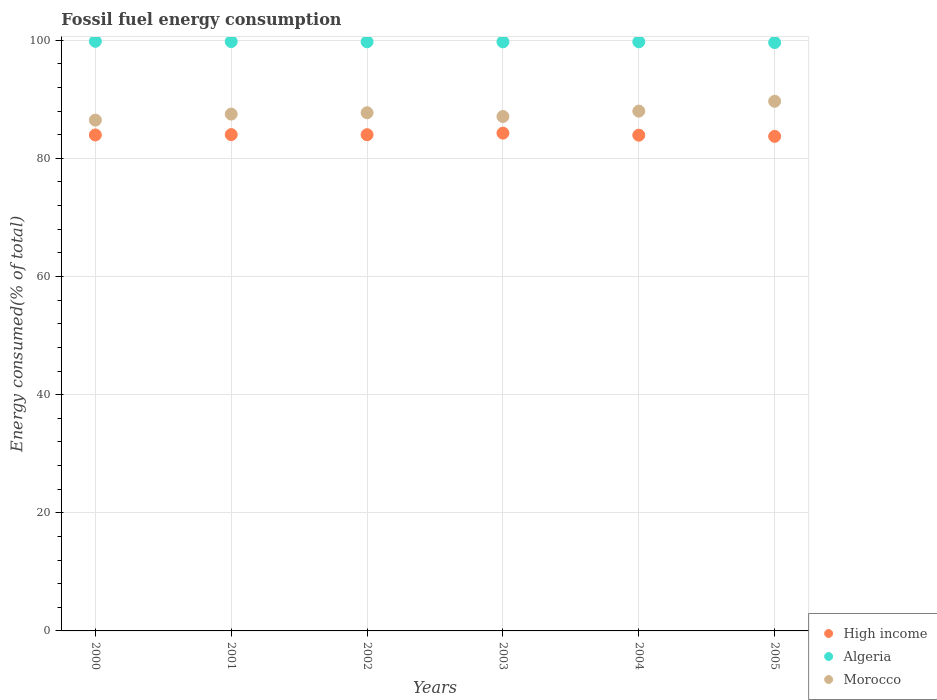How many different coloured dotlines are there?
Your response must be concise. 3. What is the percentage of energy consumed in Algeria in 2004?
Offer a very short reply. 99.74. Across all years, what is the maximum percentage of energy consumed in High income?
Provide a short and direct response. 84.27. Across all years, what is the minimum percentage of energy consumed in Morocco?
Your answer should be compact. 86.48. In which year was the percentage of energy consumed in Algeria maximum?
Provide a succinct answer. 2000. What is the total percentage of energy consumed in Morocco in the graph?
Your response must be concise. 526.45. What is the difference between the percentage of energy consumed in Morocco in 2002 and that in 2005?
Give a very brief answer. -1.94. What is the difference between the percentage of energy consumed in High income in 2002 and the percentage of energy consumed in Morocco in 2005?
Give a very brief answer. -5.66. What is the average percentage of energy consumed in Morocco per year?
Your response must be concise. 87.74. In the year 2002, what is the difference between the percentage of energy consumed in Algeria and percentage of energy consumed in High income?
Offer a very short reply. 15.73. What is the ratio of the percentage of energy consumed in Morocco in 2000 to that in 2002?
Your answer should be very brief. 0.99. Is the difference between the percentage of energy consumed in Algeria in 2002 and 2004 greater than the difference between the percentage of energy consumed in High income in 2002 and 2004?
Offer a very short reply. No. What is the difference between the highest and the second highest percentage of energy consumed in Algeria?
Make the answer very short. 0.04. What is the difference between the highest and the lowest percentage of energy consumed in Algeria?
Your answer should be very brief. 0.21. Is the sum of the percentage of energy consumed in Morocco in 2002 and 2005 greater than the maximum percentage of energy consumed in High income across all years?
Your response must be concise. Yes. How many dotlines are there?
Give a very brief answer. 3. Where does the legend appear in the graph?
Give a very brief answer. Bottom right. How many legend labels are there?
Provide a short and direct response. 3. How are the legend labels stacked?
Make the answer very short. Vertical. What is the title of the graph?
Keep it short and to the point. Fossil fuel energy consumption. What is the label or title of the X-axis?
Your answer should be very brief. Years. What is the label or title of the Y-axis?
Provide a succinct answer. Energy consumed(% of total). What is the Energy consumed(% of total) in High income in 2000?
Provide a succinct answer. 83.96. What is the Energy consumed(% of total) in Algeria in 2000?
Your answer should be very brief. 99.82. What is the Energy consumed(% of total) of Morocco in 2000?
Provide a succinct answer. 86.48. What is the Energy consumed(% of total) of High income in 2001?
Ensure brevity in your answer.  84.02. What is the Energy consumed(% of total) in Algeria in 2001?
Provide a short and direct response. 99.78. What is the Energy consumed(% of total) in Morocco in 2001?
Make the answer very short. 87.49. What is the Energy consumed(% of total) in High income in 2002?
Keep it short and to the point. 84. What is the Energy consumed(% of total) in Algeria in 2002?
Offer a terse response. 99.74. What is the Energy consumed(% of total) in Morocco in 2002?
Provide a short and direct response. 87.72. What is the Energy consumed(% of total) of High income in 2003?
Your answer should be very brief. 84.27. What is the Energy consumed(% of total) in Algeria in 2003?
Keep it short and to the point. 99.73. What is the Energy consumed(% of total) of Morocco in 2003?
Make the answer very short. 87.09. What is the Energy consumed(% of total) in High income in 2004?
Ensure brevity in your answer.  83.93. What is the Energy consumed(% of total) in Algeria in 2004?
Give a very brief answer. 99.74. What is the Energy consumed(% of total) of Morocco in 2004?
Provide a succinct answer. 88. What is the Energy consumed(% of total) of High income in 2005?
Make the answer very short. 83.73. What is the Energy consumed(% of total) in Algeria in 2005?
Your answer should be compact. 99.61. What is the Energy consumed(% of total) of Morocco in 2005?
Your response must be concise. 89.67. Across all years, what is the maximum Energy consumed(% of total) in High income?
Give a very brief answer. 84.27. Across all years, what is the maximum Energy consumed(% of total) of Algeria?
Keep it short and to the point. 99.82. Across all years, what is the maximum Energy consumed(% of total) in Morocco?
Make the answer very short. 89.67. Across all years, what is the minimum Energy consumed(% of total) of High income?
Provide a short and direct response. 83.73. Across all years, what is the minimum Energy consumed(% of total) in Algeria?
Provide a short and direct response. 99.61. Across all years, what is the minimum Energy consumed(% of total) in Morocco?
Provide a succinct answer. 86.48. What is the total Energy consumed(% of total) in High income in the graph?
Offer a very short reply. 503.92. What is the total Energy consumed(% of total) of Algeria in the graph?
Give a very brief answer. 598.41. What is the total Energy consumed(% of total) in Morocco in the graph?
Provide a succinct answer. 526.45. What is the difference between the Energy consumed(% of total) in High income in 2000 and that in 2001?
Give a very brief answer. -0.06. What is the difference between the Energy consumed(% of total) of Algeria in 2000 and that in 2001?
Ensure brevity in your answer.  0.04. What is the difference between the Energy consumed(% of total) in Morocco in 2000 and that in 2001?
Give a very brief answer. -1.02. What is the difference between the Energy consumed(% of total) of High income in 2000 and that in 2002?
Make the answer very short. -0.04. What is the difference between the Energy consumed(% of total) in Algeria in 2000 and that in 2002?
Keep it short and to the point. 0.08. What is the difference between the Energy consumed(% of total) of Morocco in 2000 and that in 2002?
Offer a very short reply. -1.25. What is the difference between the Energy consumed(% of total) of High income in 2000 and that in 2003?
Offer a terse response. -0.31. What is the difference between the Energy consumed(% of total) of Algeria in 2000 and that in 2003?
Offer a terse response. 0.08. What is the difference between the Energy consumed(% of total) of Morocco in 2000 and that in 2003?
Your response must be concise. -0.61. What is the difference between the Energy consumed(% of total) of High income in 2000 and that in 2004?
Your answer should be very brief. 0.04. What is the difference between the Energy consumed(% of total) of Algeria in 2000 and that in 2004?
Ensure brevity in your answer.  0.08. What is the difference between the Energy consumed(% of total) in Morocco in 2000 and that in 2004?
Ensure brevity in your answer.  -1.52. What is the difference between the Energy consumed(% of total) of High income in 2000 and that in 2005?
Your answer should be very brief. 0.24. What is the difference between the Energy consumed(% of total) of Algeria in 2000 and that in 2005?
Provide a short and direct response. 0.21. What is the difference between the Energy consumed(% of total) in Morocco in 2000 and that in 2005?
Make the answer very short. -3.19. What is the difference between the Energy consumed(% of total) of High income in 2001 and that in 2002?
Provide a short and direct response. 0.02. What is the difference between the Energy consumed(% of total) in Algeria in 2001 and that in 2002?
Provide a succinct answer. 0.04. What is the difference between the Energy consumed(% of total) of Morocco in 2001 and that in 2002?
Your response must be concise. -0.23. What is the difference between the Energy consumed(% of total) of High income in 2001 and that in 2003?
Offer a very short reply. -0.25. What is the difference between the Energy consumed(% of total) in Algeria in 2001 and that in 2003?
Make the answer very short. 0.04. What is the difference between the Energy consumed(% of total) in Morocco in 2001 and that in 2003?
Give a very brief answer. 0.4. What is the difference between the Energy consumed(% of total) in High income in 2001 and that in 2004?
Offer a terse response. 0.1. What is the difference between the Energy consumed(% of total) of Algeria in 2001 and that in 2004?
Offer a terse response. 0.04. What is the difference between the Energy consumed(% of total) of Morocco in 2001 and that in 2004?
Provide a succinct answer. -0.5. What is the difference between the Energy consumed(% of total) in High income in 2001 and that in 2005?
Offer a very short reply. 0.3. What is the difference between the Energy consumed(% of total) in Algeria in 2001 and that in 2005?
Ensure brevity in your answer.  0.17. What is the difference between the Energy consumed(% of total) of Morocco in 2001 and that in 2005?
Keep it short and to the point. -2.17. What is the difference between the Energy consumed(% of total) in High income in 2002 and that in 2003?
Keep it short and to the point. -0.27. What is the difference between the Energy consumed(% of total) of Algeria in 2002 and that in 2003?
Your answer should be very brief. 0.01. What is the difference between the Energy consumed(% of total) in Morocco in 2002 and that in 2003?
Your response must be concise. 0.63. What is the difference between the Energy consumed(% of total) in High income in 2002 and that in 2004?
Make the answer very short. 0.08. What is the difference between the Energy consumed(% of total) of Algeria in 2002 and that in 2004?
Your answer should be compact. 0. What is the difference between the Energy consumed(% of total) of Morocco in 2002 and that in 2004?
Provide a short and direct response. -0.27. What is the difference between the Energy consumed(% of total) in High income in 2002 and that in 2005?
Ensure brevity in your answer.  0.28. What is the difference between the Energy consumed(% of total) in Algeria in 2002 and that in 2005?
Your answer should be compact. 0.13. What is the difference between the Energy consumed(% of total) in Morocco in 2002 and that in 2005?
Give a very brief answer. -1.94. What is the difference between the Energy consumed(% of total) in High income in 2003 and that in 2004?
Your answer should be compact. 0.35. What is the difference between the Energy consumed(% of total) in Algeria in 2003 and that in 2004?
Provide a succinct answer. -0.01. What is the difference between the Energy consumed(% of total) in Morocco in 2003 and that in 2004?
Offer a very short reply. -0.91. What is the difference between the Energy consumed(% of total) in High income in 2003 and that in 2005?
Your answer should be compact. 0.55. What is the difference between the Energy consumed(% of total) of Algeria in 2003 and that in 2005?
Your response must be concise. 0.12. What is the difference between the Energy consumed(% of total) of Morocco in 2003 and that in 2005?
Your answer should be compact. -2.57. What is the difference between the Energy consumed(% of total) of High income in 2004 and that in 2005?
Keep it short and to the point. 0.2. What is the difference between the Energy consumed(% of total) of Algeria in 2004 and that in 2005?
Your answer should be very brief. 0.13. What is the difference between the Energy consumed(% of total) in Morocco in 2004 and that in 2005?
Make the answer very short. -1.67. What is the difference between the Energy consumed(% of total) of High income in 2000 and the Energy consumed(% of total) of Algeria in 2001?
Provide a succinct answer. -15.81. What is the difference between the Energy consumed(% of total) of High income in 2000 and the Energy consumed(% of total) of Morocco in 2001?
Offer a very short reply. -3.53. What is the difference between the Energy consumed(% of total) of Algeria in 2000 and the Energy consumed(% of total) of Morocco in 2001?
Provide a succinct answer. 12.32. What is the difference between the Energy consumed(% of total) of High income in 2000 and the Energy consumed(% of total) of Algeria in 2002?
Your answer should be very brief. -15.78. What is the difference between the Energy consumed(% of total) in High income in 2000 and the Energy consumed(% of total) in Morocco in 2002?
Provide a short and direct response. -3.76. What is the difference between the Energy consumed(% of total) of Algeria in 2000 and the Energy consumed(% of total) of Morocco in 2002?
Give a very brief answer. 12.09. What is the difference between the Energy consumed(% of total) of High income in 2000 and the Energy consumed(% of total) of Algeria in 2003?
Offer a very short reply. -15.77. What is the difference between the Energy consumed(% of total) in High income in 2000 and the Energy consumed(% of total) in Morocco in 2003?
Provide a succinct answer. -3.13. What is the difference between the Energy consumed(% of total) of Algeria in 2000 and the Energy consumed(% of total) of Morocco in 2003?
Ensure brevity in your answer.  12.72. What is the difference between the Energy consumed(% of total) in High income in 2000 and the Energy consumed(% of total) in Algeria in 2004?
Your response must be concise. -15.77. What is the difference between the Energy consumed(% of total) of High income in 2000 and the Energy consumed(% of total) of Morocco in 2004?
Provide a short and direct response. -4.04. What is the difference between the Energy consumed(% of total) in Algeria in 2000 and the Energy consumed(% of total) in Morocco in 2004?
Give a very brief answer. 11.82. What is the difference between the Energy consumed(% of total) in High income in 2000 and the Energy consumed(% of total) in Algeria in 2005?
Your response must be concise. -15.65. What is the difference between the Energy consumed(% of total) in High income in 2000 and the Energy consumed(% of total) in Morocco in 2005?
Your answer should be very brief. -5.7. What is the difference between the Energy consumed(% of total) in Algeria in 2000 and the Energy consumed(% of total) in Morocco in 2005?
Give a very brief answer. 10.15. What is the difference between the Energy consumed(% of total) of High income in 2001 and the Energy consumed(% of total) of Algeria in 2002?
Keep it short and to the point. -15.71. What is the difference between the Energy consumed(% of total) of High income in 2001 and the Energy consumed(% of total) of Morocco in 2002?
Ensure brevity in your answer.  -3.7. What is the difference between the Energy consumed(% of total) in Algeria in 2001 and the Energy consumed(% of total) in Morocco in 2002?
Your answer should be very brief. 12.05. What is the difference between the Energy consumed(% of total) in High income in 2001 and the Energy consumed(% of total) in Algeria in 2003?
Your answer should be very brief. -15.71. What is the difference between the Energy consumed(% of total) of High income in 2001 and the Energy consumed(% of total) of Morocco in 2003?
Ensure brevity in your answer.  -3.07. What is the difference between the Energy consumed(% of total) in Algeria in 2001 and the Energy consumed(% of total) in Morocco in 2003?
Provide a succinct answer. 12.68. What is the difference between the Energy consumed(% of total) of High income in 2001 and the Energy consumed(% of total) of Algeria in 2004?
Provide a succinct answer. -15.71. What is the difference between the Energy consumed(% of total) in High income in 2001 and the Energy consumed(% of total) in Morocco in 2004?
Your answer should be compact. -3.97. What is the difference between the Energy consumed(% of total) in Algeria in 2001 and the Energy consumed(% of total) in Morocco in 2004?
Your answer should be very brief. 11.78. What is the difference between the Energy consumed(% of total) in High income in 2001 and the Energy consumed(% of total) in Algeria in 2005?
Ensure brevity in your answer.  -15.59. What is the difference between the Energy consumed(% of total) of High income in 2001 and the Energy consumed(% of total) of Morocco in 2005?
Provide a succinct answer. -5.64. What is the difference between the Energy consumed(% of total) of Algeria in 2001 and the Energy consumed(% of total) of Morocco in 2005?
Offer a terse response. 10.11. What is the difference between the Energy consumed(% of total) of High income in 2002 and the Energy consumed(% of total) of Algeria in 2003?
Ensure brevity in your answer.  -15.73. What is the difference between the Energy consumed(% of total) of High income in 2002 and the Energy consumed(% of total) of Morocco in 2003?
Give a very brief answer. -3.09. What is the difference between the Energy consumed(% of total) in Algeria in 2002 and the Energy consumed(% of total) in Morocco in 2003?
Provide a short and direct response. 12.65. What is the difference between the Energy consumed(% of total) in High income in 2002 and the Energy consumed(% of total) in Algeria in 2004?
Make the answer very short. -15.73. What is the difference between the Energy consumed(% of total) of High income in 2002 and the Energy consumed(% of total) of Morocco in 2004?
Offer a terse response. -3.99. What is the difference between the Energy consumed(% of total) in Algeria in 2002 and the Energy consumed(% of total) in Morocco in 2004?
Provide a short and direct response. 11.74. What is the difference between the Energy consumed(% of total) in High income in 2002 and the Energy consumed(% of total) in Algeria in 2005?
Keep it short and to the point. -15.6. What is the difference between the Energy consumed(% of total) of High income in 2002 and the Energy consumed(% of total) of Morocco in 2005?
Give a very brief answer. -5.66. What is the difference between the Energy consumed(% of total) in Algeria in 2002 and the Energy consumed(% of total) in Morocco in 2005?
Provide a succinct answer. 10.07. What is the difference between the Energy consumed(% of total) in High income in 2003 and the Energy consumed(% of total) in Algeria in 2004?
Offer a very short reply. -15.46. What is the difference between the Energy consumed(% of total) in High income in 2003 and the Energy consumed(% of total) in Morocco in 2004?
Ensure brevity in your answer.  -3.72. What is the difference between the Energy consumed(% of total) of Algeria in 2003 and the Energy consumed(% of total) of Morocco in 2004?
Offer a terse response. 11.73. What is the difference between the Energy consumed(% of total) of High income in 2003 and the Energy consumed(% of total) of Algeria in 2005?
Offer a terse response. -15.34. What is the difference between the Energy consumed(% of total) in High income in 2003 and the Energy consumed(% of total) in Morocco in 2005?
Provide a short and direct response. -5.39. What is the difference between the Energy consumed(% of total) in Algeria in 2003 and the Energy consumed(% of total) in Morocco in 2005?
Keep it short and to the point. 10.07. What is the difference between the Energy consumed(% of total) in High income in 2004 and the Energy consumed(% of total) in Algeria in 2005?
Provide a short and direct response. -15.68. What is the difference between the Energy consumed(% of total) of High income in 2004 and the Energy consumed(% of total) of Morocco in 2005?
Your answer should be very brief. -5.74. What is the difference between the Energy consumed(% of total) in Algeria in 2004 and the Energy consumed(% of total) in Morocco in 2005?
Give a very brief answer. 10.07. What is the average Energy consumed(% of total) in High income per year?
Offer a very short reply. 83.99. What is the average Energy consumed(% of total) in Algeria per year?
Your answer should be very brief. 99.73. What is the average Energy consumed(% of total) of Morocco per year?
Provide a succinct answer. 87.74. In the year 2000, what is the difference between the Energy consumed(% of total) in High income and Energy consumed(% of total) in Algeria?
Offer a terse response. -15.85. In the year 2000, what is the difference between the Energy consumed(% of total) of High income and Energy consumed(% of total) of Morocco?
Ensure brevity in your answer.  -2.52. In the year 2000, what is the difference between the Energy consumed(% of total) of Algeria and Energy consumed(% of total) of Morocco?
Offer a terse response. 13.34. In the year 2001, what is the difference between the Energy consumed(% of total) of High income and Energy consumed(% of total) of Algeria?
Make the answer very short. -15.75. In the year 2001, what is the difference between the Energy consumed(% of total) in High income and Energy consumed(% of total) in Morocco?
Offer a terse response. -3.47. In the year 2001, what is the difference between the Energy consumed(% of total) in Algeria and Energy consumed(% of total) in Morocco?
Give a very brief answer. 12.28. In the year 2002, what is the difference between the Energy consumed(% of total) of High income and Energy consumed(% of total) of Algeria?
Offer a very short reply. -15.73. In the year 2002, what is the difference between the Energy consumed(% of total) in High income and Energy consumed(% of total) in Morocco?
Keep it short and to the point. -3.72. In the year 2002, what is the difference between the Energy consumed(% of total) in Algeria and Energy consumed(% of total) in Morocco?
Your response must be concise. 12.01. In the year 2003, what is the difference between the Energy consumed(% of total) in High income and Energy consumed(% of total) in Algeria?
Provide a short and direct response. -15.46. In the year 2003, what is the difference between the Energy consumed(% of total) of High income and Energy consumed(% of total) of Morocco?
Offer a terse response. -2.82. In the year 2003, what is the difference between the Energy consumed(% of total) of Algeria and Energy consumed(% of total) of Morocco?
Ensure brevity in your answer.  12.64. In the year 2004, what is the difference between the Energy consumed(% of total) of High income and Energy consumed(% of total) of Algeria?
Your response must be concise. -15.81. In the year 2004, what is the difference between the Energy consumed(% of total) in High income and Energy consumed(% of total) in Morocco?
Your response must be concise. -4.07. In the year 2004, what is the difference between the Energy consumed(% of total) in Algeria and Energy consumed(% of total) in Morocco?
Your answer should be compact. 11.74. In the year 2005, what is the difference between the Energy consumed(% of total) of High income and Energy consumed(% of total) of Algeria?
Offer a very short reply. -15.88. In the year 2005, what is the difference between the Energy consumed(% of total) of High income and Energy consumed(% of total) of Morocco?
Your response must be concise. -5.94. In the year 2005, what is the difference between the Energy consumed(% of total) in Algeria and Energy consumed(% of total) in Morocco?
Ensure brevity in your answer.  9.94. What is the ratio of the Energy consumed(% of total) in High income in 2000 to that in 2001?
Your answer should be very brief. 1. What is the ratio of the Energy consumed(% of total) of Algeria in 2000 to that in 2001?
Offer a very short reply. 1. What is the ratio of the Energy consumed(% of total) in Morocco in 2000 to that in 2001?
Offer a terse response. 0.99. What is the ratio of the Energy consumed(% of total) in Morocco in 2000 to that in 2002?
Your answer should be very brief. 0.99. What is the ratio of the Energy consumed(% of total) of High income in 2000 to that in 2003?
Make the answer very short. 1. What is the ratio of the Energy consumed(% of total) of Algeria in 2000 to that in 2003?
Give a very brief answer. 1. What is the ratio of the Energy consumed(% of total) of Morocco in 2000 to that in 2003?
Provide a short and direct response. 0.99. What is the ratio of the Energy consumed(% of total) of Algeria in 2000 to that in 2004?
Your answer should be compact. 1. What is the ratio of the Energy consumed(% of total) in Morocco in 2000 to that in 2004?
Your answer should be compact. 0.98. What is the ratio of the Energy consumed(% of total) of High income in 2000 to that in 2005?
Your answer should be very brief. 1. What is the ratio of the Energy consumed(% of total) in Algeria in 2000 to that in 2005?
Keep it short and to the point. 1. What is the ratio of the Energy consumed(% of total) in Morocco in 2000 to that in 2005?
Make the answer very short. 0.96. What is the ratio of the Energy consumed(% of total) in High income in 2001 to that in 2002?
Make the answer very short. 1. What is the ratio of the Energy consumed(% of total) of High income in 2001 to that in 2003?
Offer a terse response. 1. What is the ratio of the Energy consumed(% of total) of High income in 2001 to that in 2004?
Your response must be concise. 1. What is the ratio of the Energy consumed(% of total) of Algeria in 2001 to that in 2004?
Your answer should be compact. 1. What is the ratio of the Energy consumed(% of total) of Morocco in 2001 to that in 2004?
Keep it short and to the point. 0.99. What is the ratio of the Energy consumed(% of total) in High income in 2001 to that in 2005?
Make the answer very short. 1. What is the ratio of the Energy consumed(% of total) in Morocco in 2001 to that in 2005?
Provide a succinct answer. 0.98. What is the ratio of the Energy consumed(% of total) of Algeria in 2002 to that in 2003?
Your answer should be compact. 1. What is the ratio of the Energy consumed(% of total) in Morocco in 2002 to that in 2003?
Offer a terse response. 1.01. What is the ratio of the Energy consumed(% of total) of High income in 2002 to that in 2004?
Provide a succinct answer. 1. What is the ratio of the Energy consumed(% of total) in High income in 2002 to that in 2005?
Give a very brief answer. 1. What is the ratio of the Energy consumed(% of total) in Algeria in 2002 to that in 2005?
Provide a short and direct response. 1. What is the ratio of the Energy consumed(% of total) of Morocco in 2002 to that in 2005?
Give a very brief answer. 0.98. What is the ratio of the Energy consumed(% of total) of High income in 2003 to that in 2004?
Your response must be concise. 1. What is the ratio of the Energy consumed(% of total) in Algeria in 2003 to that in 2004?
Provide a succinct answer. 1. What is the ratio of the Energy consumed(% of total) of Morocco in 2003 to that in 2005?
Ensure brevity in your answer.  0.97. What is the ratio of the Energy consumed(% of total) in High income in 2004 to that in 2005?
Offer a terse response. 1. What is the ratio of the Energy consumed(% of total) of Algeria in 2004 to that in 2005?
Your response must be concise. 1. What is the ratio of the Energy consumed(% of total) of Morocco in 2004 to that in 2005?
Your response must be concise. 0.98. What is the difference between the highest and the second highest Energy consumed(% of total) of High income?
Provide a succinct answer. 0.25. What is the difference between the highest and the second highest Energy consumed(% of total) of Algeria?
Your answer should be very brief. 0.04. What is the difference between the highest and the second highest Energy consumed(% of total) in Morocco?
Keep it short and to the point. 1.67. What is the difference between the highest and the lowest Energy consumed(% of total) in High income?
Offer a very short reply. 0.55. What is the difference between the highest and the lowest Energy consumed(% of total) of Algeria?
Offer a very short reply. 0.21. What is the difference between the highest and the lowest Energy consumed(% of total) in Morocco?
Offer a very short reply. 3.19. 